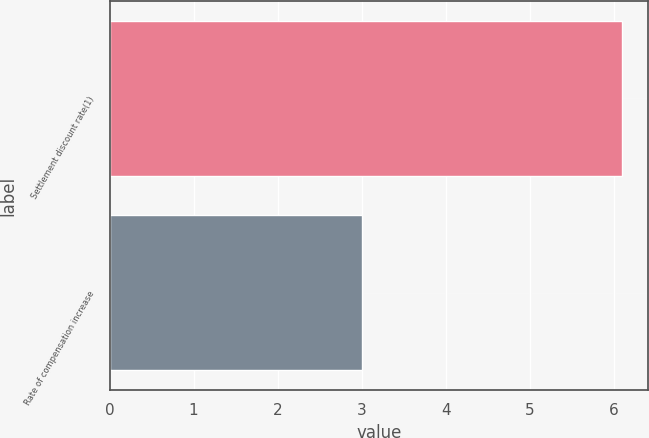Convert chart. <chart><loc_0><loc_0><loc_500><loc_500><bar_chart><fcel>Settlement discount rate(1)<fcel>Rate of compensation increase<nl><fcel>6.1<fcel>3<nl></chart> 